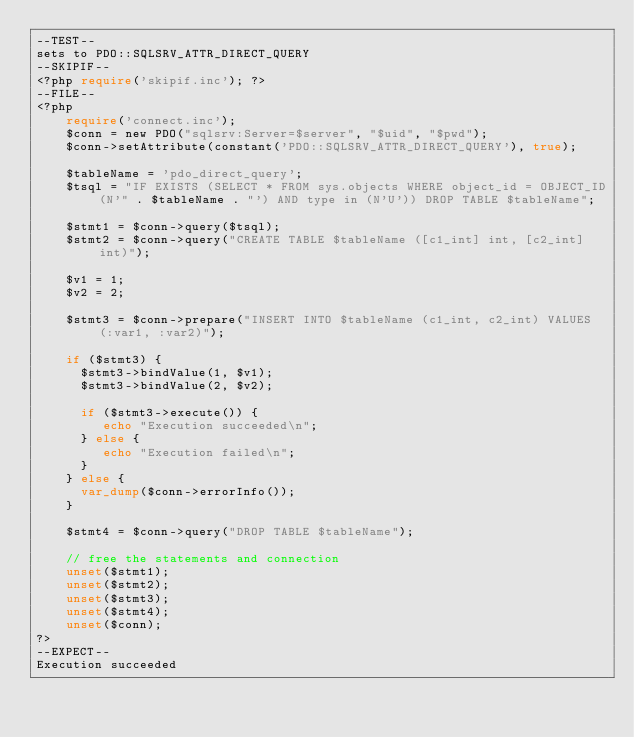Convert code to text. <code><loc_0><loc_0><loc_500><loc_500><_PHP_>--TEST--
sets to PDO::SQLSRV_ATTR_DIRECT_QUERY
--SKIPIF--
<?php require('skipif.inc'); ?>
--FILE--
<?php
    require('connect.inc');	
    $conn = new PDO("sqlsrv:Server=$server", "$uid", "$pwd");
    $conn->setAttribute(constant('PDO::SQLSRV_ATTR_DIRECT_QUERY'), true);

    $tableName = 'pdo_direct_query';
    $tsql = "IF EXISTS (SELECT * FROM sys.objects WHERE object_id = OBJECT_ID(N'" . $tableName . "') AND type in (N'U')) DROP TABLE $tableName";

    $stmt1 = $conn->query($tsql);
    $stmt2 = $conn->query("CREATE TABLE $tableName ([c1_int] int, [c2_int] int)");

    $v1 = 1;
    $v2 = 2;

    $stmt3 = $conn->prepare("INSERT INTO $tableName (c1_int, c2_int) VALUES (:var1, :var2)");

    if ($stmt3) {
      $stmt3->bindValue(1, $v1);
      $stmt3->bindValue(2, $v2);

      if ($stmt3->execute()) {
         echo "Execution succeeded\n";     
      } else {
         echo "Execution failed\n";
      }
    } else {
      var_dump($conn->errorInfo());
    }

    $stmt4 = $conn->query("DROP TABLE $tableName");

    // free the statements and connection
    unset($stmt1);
    unset($stmt2);
    unset($stmt3);
    unset($stmt4);
    unset($conn);
?>
--EXPECT--
Execution succeeded</code> 